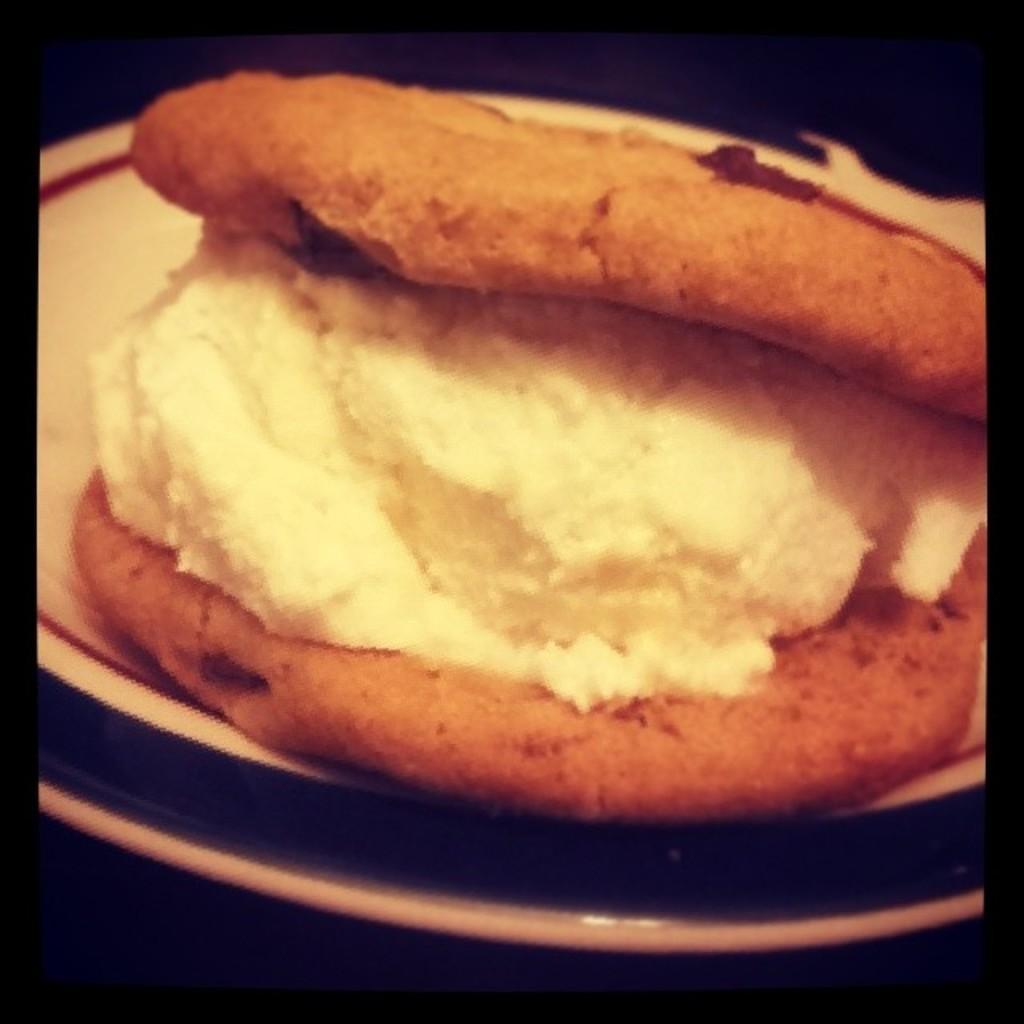Could you give a brief overview of what you see in this image? In this picture we can see food in the plate. 